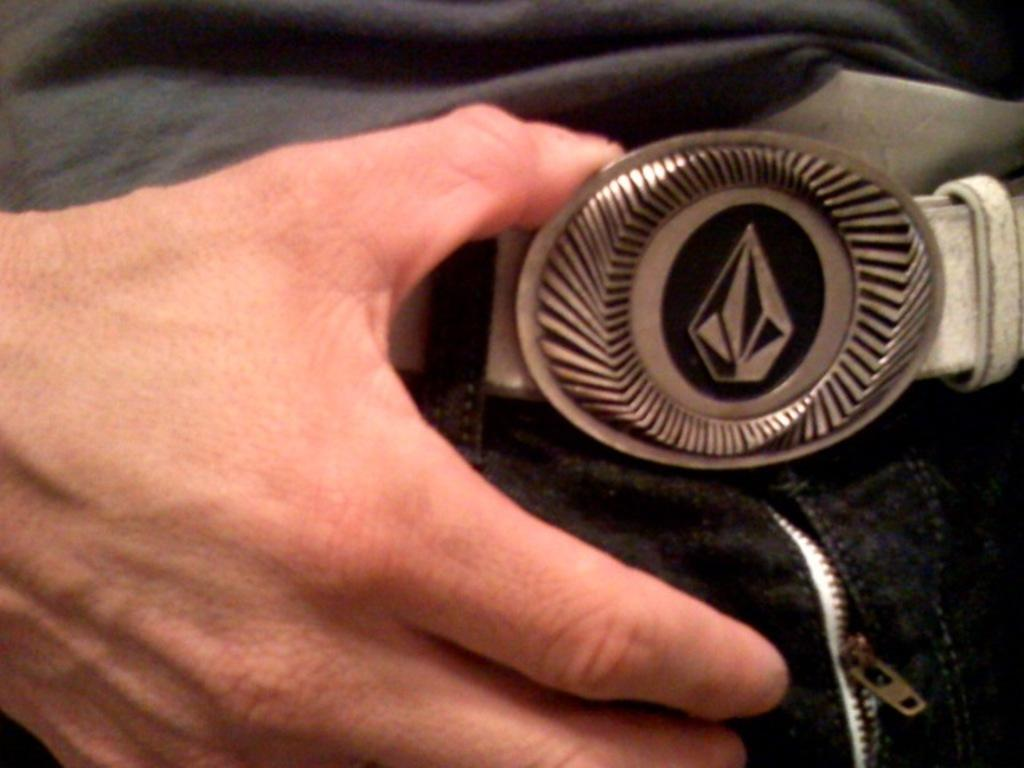What can be seen in the image related to a person's body part? There is a person's hand in the image. What is the person holding in the image? The person is holding a belt. What type of celery is being used as a prop in the image? There is no celery present in the image. What fictional character is holding the belt in the image? The image does not depict any fictional characters; it shows a person's hand holding a belt. 